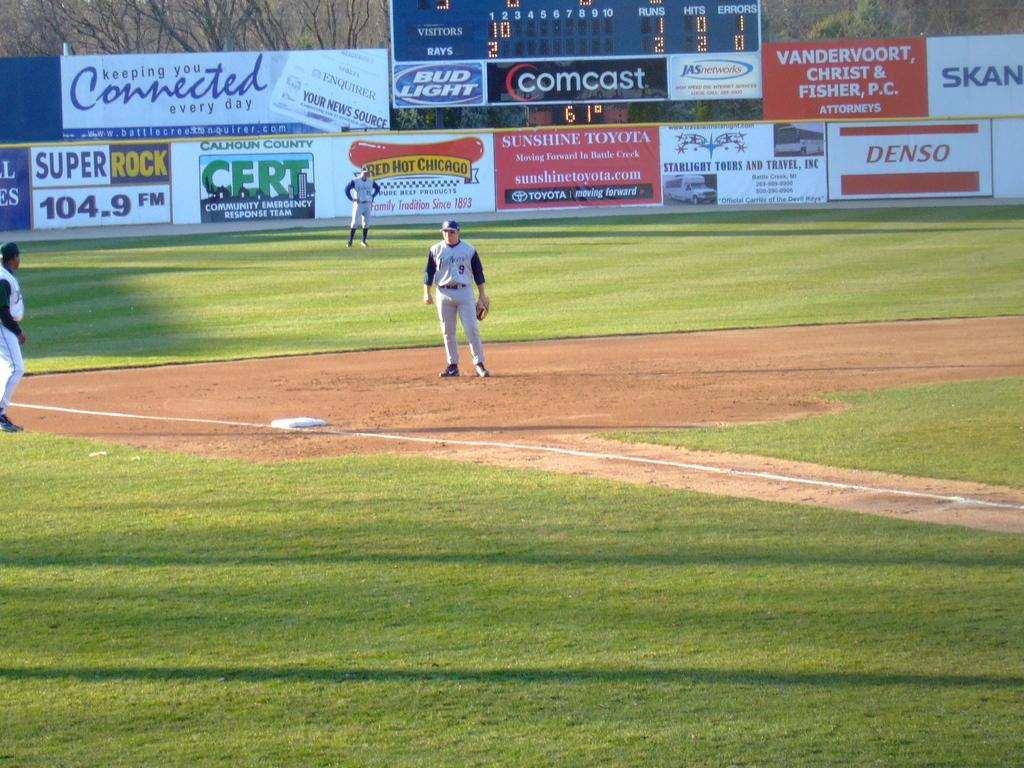<image>
Write a terse but informative summary of the picture. Rays are winning 2 to 1 says the scoreboard in the background. 